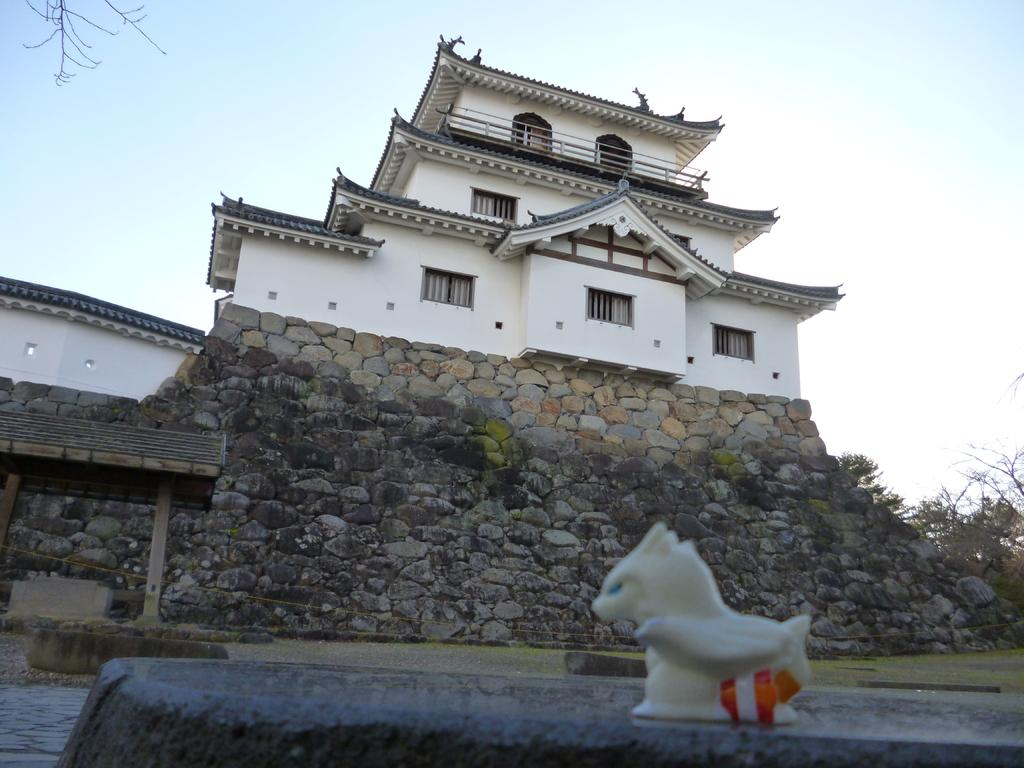What is located in the foreground of the image? There is a toy, grass, a shed, and a building in the foreground of the image. What type of vegetation can be seen in the foreground of the image? There is grass in the foreground of the image. What type of structure is present in the foreground of the image? There is a shed in the foreground of the image. What can be seen in the background of the image? There are trees and the sky visible in the background of the image. When was the image taken? The image was taken during the day. What type of wood is used to construct the drawer in the image? There is no drawer present in the image. What attraction can be seen in the background of the image? There is no attraction visible in the image; only trees and the sky are present in the background. 